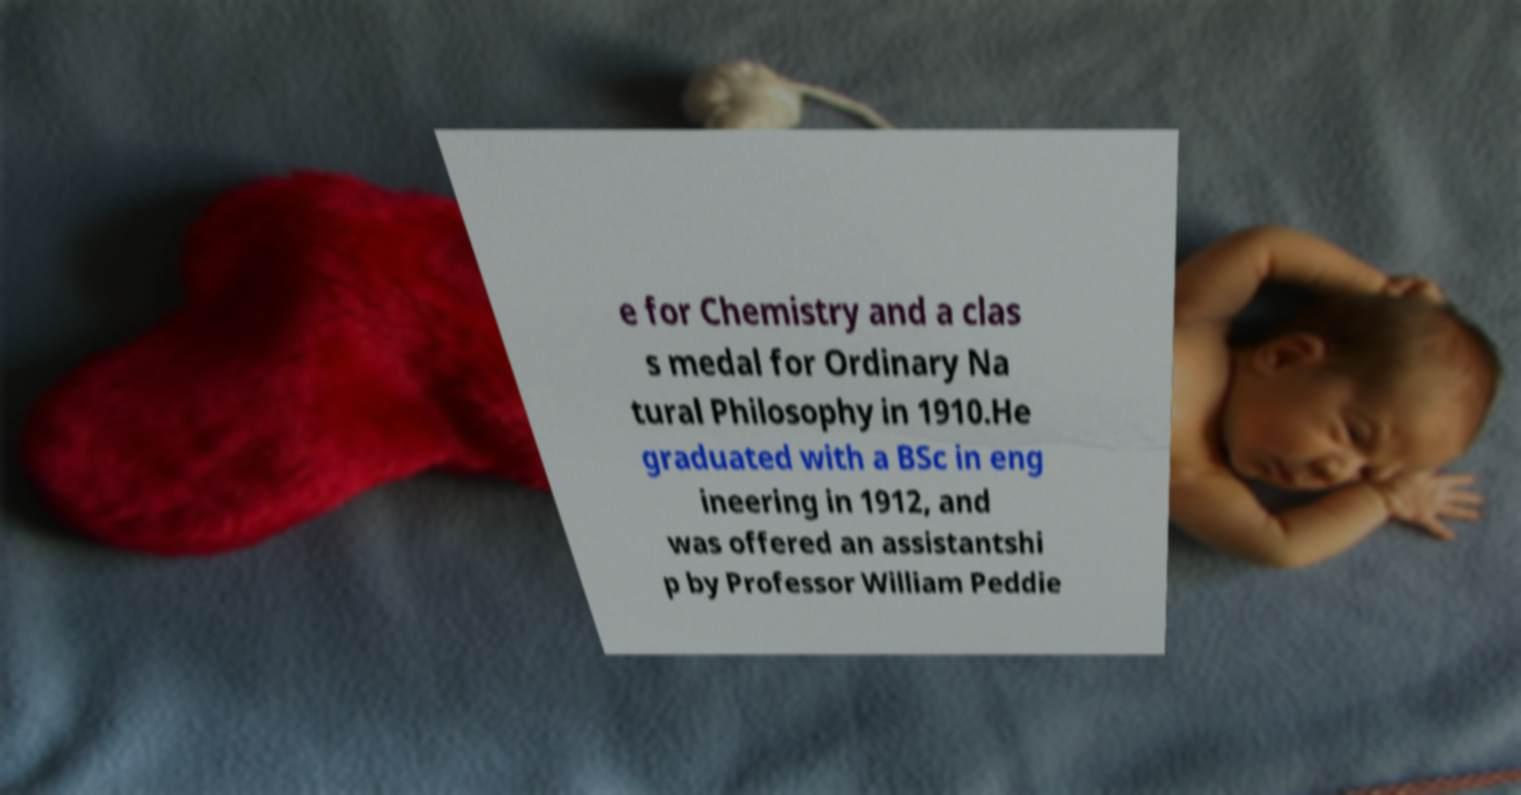I need the written content from this picture converted into text. Can you do that? e for Chemistry and a clas s medal for Ordinary Na tural Philosophy in 1910.He graduated with a BSc in eng ineering in 1912, and was offered an assistantshi p by Professor William Peddie 